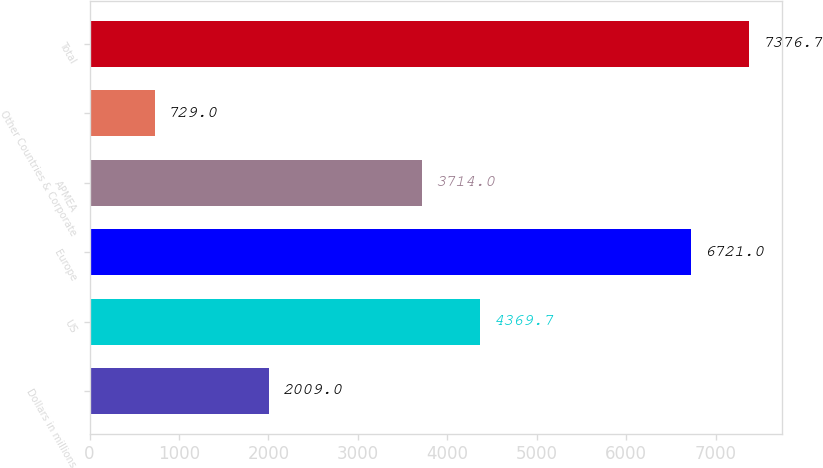Convert chart. <chart><loc_0><loc_0><loc_500><loc_500><bar_chart><fcel>Dollars in millions<fcel>US<fcel>Europe<fcel>APMEA<fcel>Other Countries & Corporate<fcel>Total<nl><fcel>2009<fcel>4369.7<fcel>6721<fcel>3714<fcel>729<fcel>7376.7<nl></chart> 